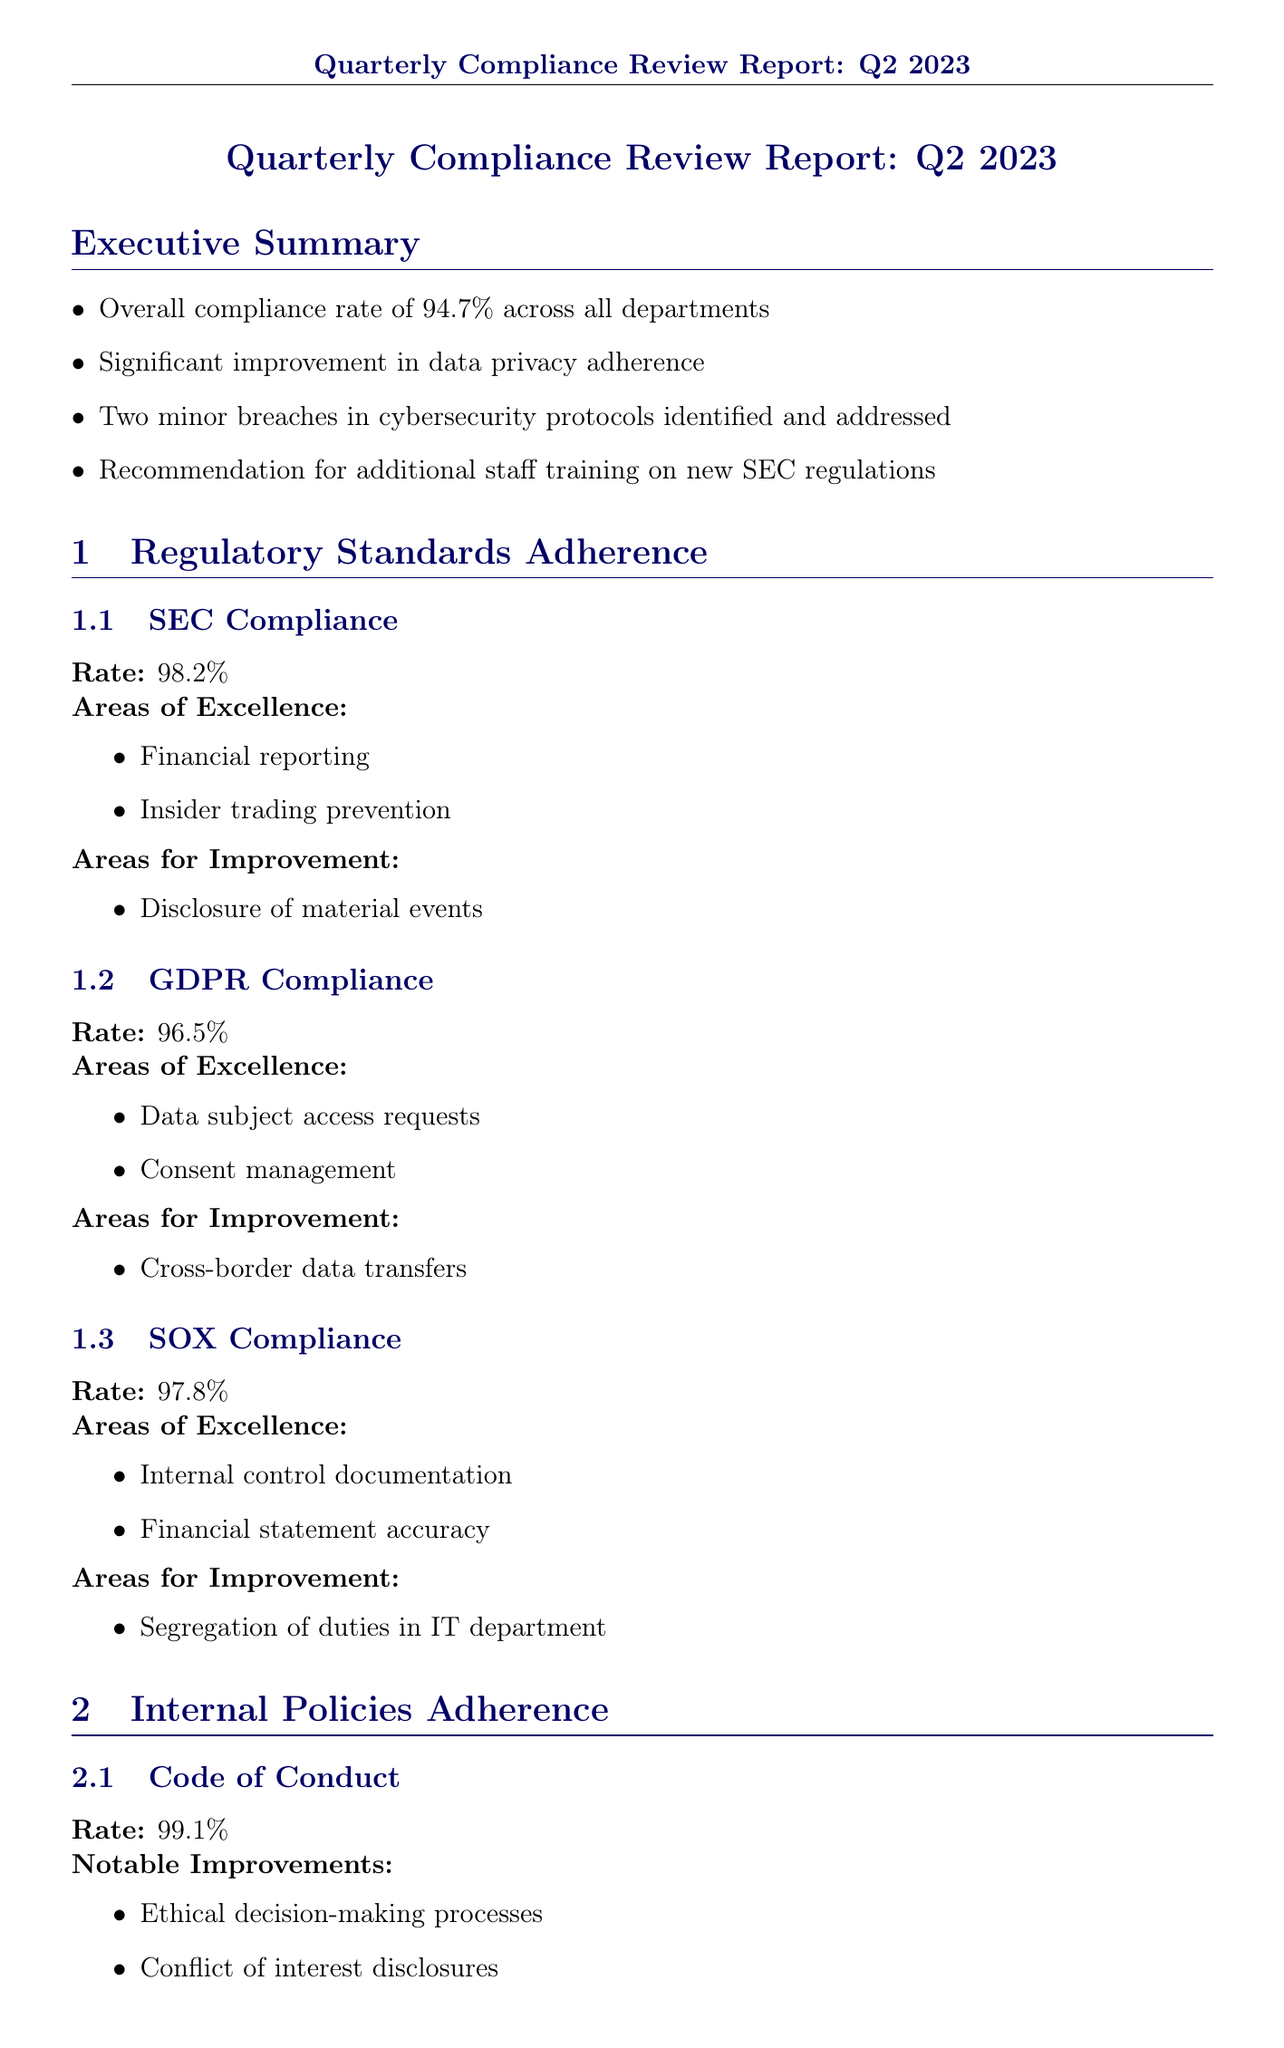What is the overall compliance rate? The overall compliance rate is reported across all departments as 94.7%.
Answer: 94.7% What is the SEC compliance rate? The SEC compliance rate is detailed as 98.2%.
Answer: 98.2% What significant improvement was noted in the report? The report states there was a significant improvement in data privacy adherence.
Answer: Data privacy adherence What is one area for improvement under GDPR compliance? The report identifies "Cross-border data transfers" as an area for improvement.
Answer: Cross-border data transfers Which department had the highest compliance rate? The Human Resources department had the highest compliance rate of 98.3%.
Answer: 98.3% What is the mitigation strategy for high-risk cybersecurity? The mitigation strategy involves implementing advanced threat detection systems and conducting regular penetration testing.
Answer: Implement advanced threat detection systems and conduct regular penetration testing What corrective action is recommended for the inconsistent application of expense approval policies? The action recommended is to conduct refresher training for all managers on expense approval procedures.
Answer: Conduct refresher training for all managers on expense approval procedures What is the proposed date for the training on updated SEC regulations? The training on updated SEC regulations is proposed for Q3 2023.
Answer: Q3 2023 What were the notable improvements in the Code of Conduct? Notable improvements include ethical decision-making processes and conflict of interest disclosures.
Answer: Ethical decision-making processes, conflict of interest disclosures 